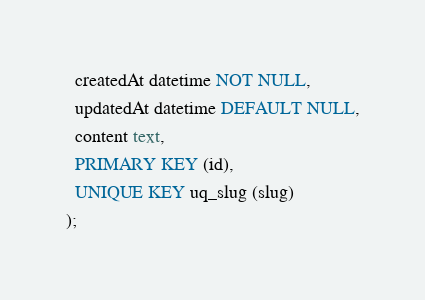Convert code to text. <code><loc_0><loc_0><loc_500><loc_500><_SQL_>  createdAt datetime NOT NULL,
  updatedAt datetime DEFAULT NULL,
  content text,
  PRIMARY KEY (id),
  UNIQUE KEY uq_slug (slug)
);

</code> 